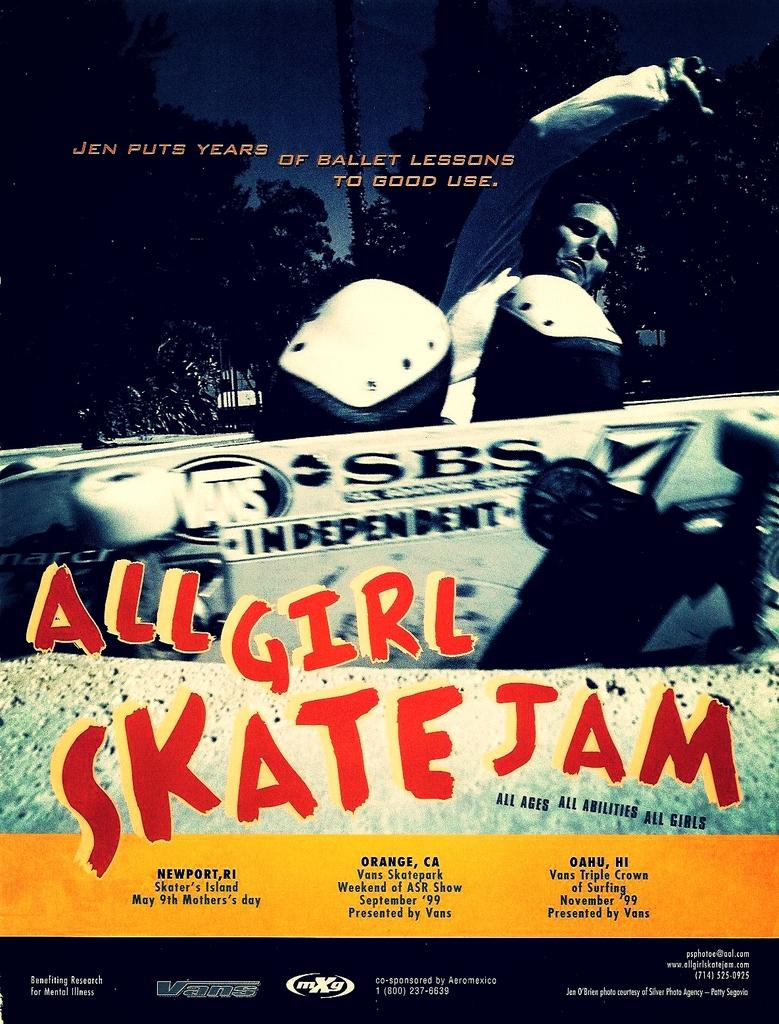<image>
Provide a brief description of the given image. The all girl skate jam will be in Oahu in November. 